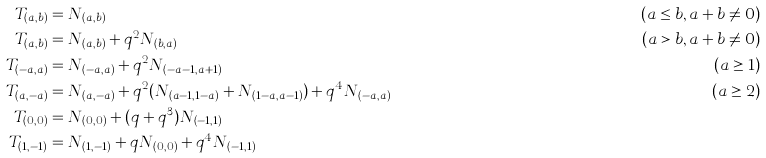<formula> <loc_0><loc_0><loc_500><loc_500>T _ { ( a , b ) } & = N _ { ( a , b ) } & \, ( a \leq b , a + b \neq 0 ) \\ T _ { ( a , b ) } & = N _ { ( a , b ) } + q ^ { 2 } N _ { ( b , a ) } & \, ( a > b , a + b \neq 0 ) \\ T _ { ( - a , a ) } & = N _ { ( - a , a ) } + q ^ { 2 } N _ { ( - a - 1 , a + 1 ) } & ( a \geq 1 ) \\ T _ { ( a , - a ) } & = N _ { ( a , - a ) } + q ^ { 2 } ( N _ { ( a - 1 , 1 - a ) } + N _ { ( 1 - a , a - 1 ) } ) + q ^ { 4 } N _ { ( - a , a ) } & ( a \geq 2 ) \\ T _ { ( 0 , 0 ) } & = N _ { ( 0 , 0 ) } + ( q + q ^ { 3 } ) N _ { ( - 1 , 1 ) } \\ T _ { ( 1 , - 1 ) } & = N _ { ( 1 , - 1 ) } + q N _ { ( 0 , 0 ) } + q ^ { 4 } N _ { ( - 1 , 1 ) }</formula> 